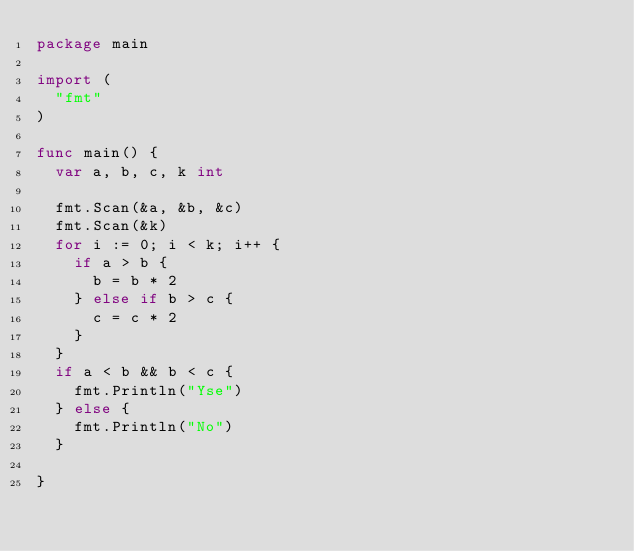<code> <loc_0><loc_0><loc_500><loc_500><_Go_>package main

import (
	"fmt"
)

func main() {
	var a, b, c, k int

	fmt.Scan(&a, &b, &c)
	fmt.Scan(&k)
	for i := 0; i < k; i++ {
		if a > b {
			b = b * 2
		} else if b > c {
			c = c * 2
		}
	}
	if a < b && b < c {
		fmt.Println("Yse")
	} else {
		fmt.Println("No")
	}

}
</code> 